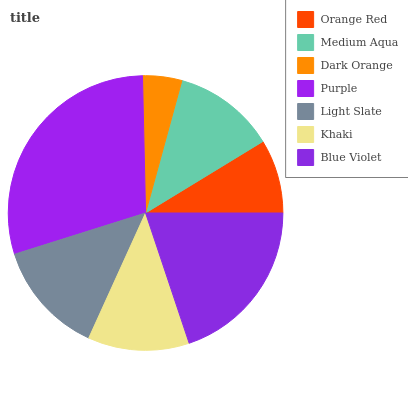Is Dark Orange the minimum?
Answer yes or no. Yes. Is Purple the maximum?
Answer yes or no. Yes. Is Medium Aqua the minimum?
Answer yes or no. No. Is Medium Aqua the maximum?
Answer yes or no. No. Is Medium Aqua greater than Orange Red?
Answer yes or no. Yes. Is Orange Red less than Medium Aqua?
Answer yes or no. Yes. Is Orange Red greater than Medium Aqua?
Answer yes or no. No. Is Medium Aqua less than Orange Red?
Answer yes or no. No. Is Medium Aqua the high median?
Answer yes or no. Yes. Is Medium Aqua the low median?
Answer yes or no. Yes. Is Blue Violet the high median?
Answer yes or no. No. Is Dark Orange the low median?
Answer yes or no. No. 